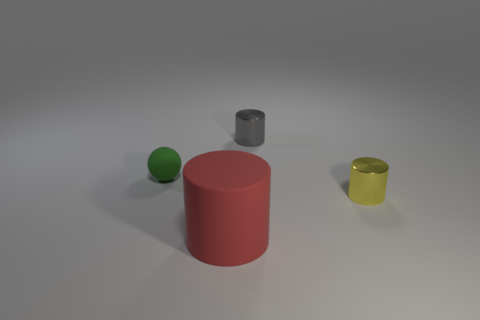The small cylinder that is the same material as the gray object is what color?
Provide a short and direct response. Yellow. There is a thing that is behind the red matte cylinder and in front of the small green matte ball; what is its size?
Your answer should be compact. Small. Is the number of large red cylinders that are in front of the big thing less than the number of small matte spheres to the right of the sphere?
Give a very brief answer. No. Is the object behind the small green ball made of the same material as the object in front of the yellow cylinder?
Your answer should be very brief. No. What shape is the object that is both to the right of the big cylinder and in front of the tiny gray cylinder?
Your answer should be very brief. Cylinder. What is the thing that is in front of the tiny cylinder in front of the green rubber sphere made of?
Offer a very short reply. Rubber. Are there more green rubber objects than small cyan rubber things?
Your answer should be compact. Yes. What material is the green ball that is the same size as the gray shiny object?
Offer a very short reply. Rubber. Are the gray cylinder and the yellow cylinder made of the same material?
Offer a terse response. Yes. What number of small gray things are made of the same material as the tiny yellow thing?
Ensure brevity in your answer.  1. 